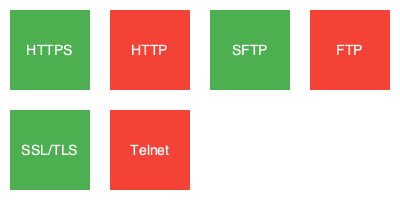Based on the icons and symbols shown, which network protocols are considered secure and compliant with financial industry standards? 1. HTTPS (Hypertext Transfer Protocol Secure):
   - Secure protocol that encrypts data in transit
   - Uses SSL/TLS for encryption
   - Compliant with financial industry standards

2. HTTP (Hypertext Transfer Protocol):
   - Unsecure protocol that transmits data in plain text
   - Vulnerable to eavesdropping and man-in-the-middle attacks
   - Not compliant with financial industry standards

3. SFTP (Secure File Transfer Protocol):
   - Secure protocol for file transfers
   - Uses SSH for encryption and authentication
   - Compliant with financial industry standards

4. FTP (File Transfer Protocol):
   - Unsecure protocol that transmits data and credentials in plain text
   - Vulnerable to interception and unauthorized access
   - Not compliant with financial industry standards

5. SSL/TLS (Secure Sockets Layer/Transport Layer Security):
   - Cryptographic protocols that provide secure communication over a network
   - Used by other secure protocols like HTTPS
   - Compliant with financial industry standards

6. Telnet:
   - Unsecure protocol for remote access
   - Transmits data and credentials in plain text
   - Vulnerable to eavesdropping and unauthorized access
   - Not compliant with financial industry standards

The secure and compliant protocols are represented by green icons, while the unsecure and non-compliant protocols are represented by red icons.
Answer: HTTPS, SFTP, SSL/TLS 